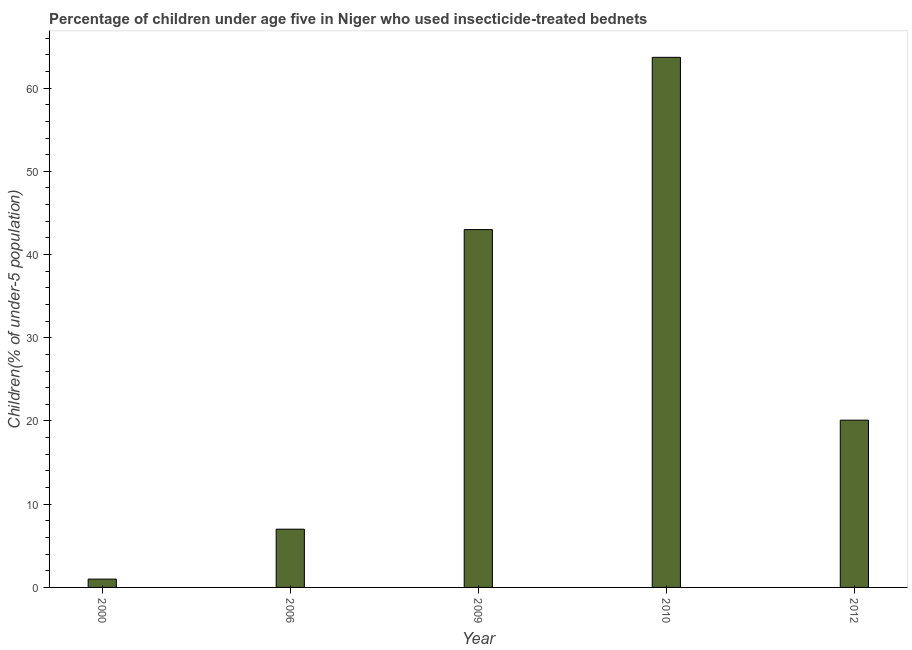What is the title of the graph?
Give a very brief answer. Percentage of children under age five in Niger who used insecticide-treated bednets. What is the label or title of the X-axis?
Your answer should be very brief. Year. What is the label or title of the Y-axis?
Your answer should be compact. Children(% of under-5 population). What is the percentage of children who use of insecticide-treated bed nets in 2012?
Your response must be concise. 20.1. Across all years, what is the maximum percentage of children who use of insecticide-treated bed nets?
Make the answer very short. 63.7. Across all years, what is the minimum percentage of children who use of insecticide-treated bed nets?
Your answer should be compact. 1. What is the sum of the percentage of children who use of insecticide-treated bed nets?
Make the answer very short. 134.8. What is the difference between the percentage of children who use of insecticide-treated bed nets in 2006 and 2012?
Provide a succinct answer. -13.1. What is the average percentage of children who use of insecticide-treated bed nets per year?
Your answer should be compact. 26.96. What is the median percentage of children who use of insecticide-treated bed nets?
Ensure brevity in your answer.  20.1. Do a majority of the years between 2006 and 2012 (inclusive) have percentage of children who use of insecticide-treated bed nets greater than 44 %?
Your answer should be very brief. No. Is the percentage of children who use of insecticide-treated bed nets in 2009 less than that in 2012?
Provide a short and direct response. No. Is the difference between the percentage of children who use of insecticide-treated bed nets in 2006 and 2012 greater than the difference between any two years?
Keep it short and to the point. No. What is the difference between the highest and the second highest percentage of children who use of insecticide-treated bed nets?
Offer a very short reply. 20.7. What is the difference between the highest and the lowest percentage of children who use of insecticide-treated bed nets?
Your response must be concise. 62.7. In how many years, is the percentage of children who use of insecticide-treated bed nets greater than the average percentage of children who use of insecticide-treated bed nets taken over all years?
Your response must be concise. 2. Are all the bars in the graph horizontal?
Provide a succinct answer. No. What is the Children(% of under-5 population) in 2000?
Offer a terse response. 1. What is the Children(% of under-5 population) in 2010?
Keep it short and to the point. 63.7. What is the Children(% of under-5 population) of 2012?
Provide a short and direct response. 20.1. What is the difference between the Children(% of under-5 population) in 2000 and 2009?
Your answer should be very brief. -42. What is the difference between the Children(% of under-5 population) in 2000 and 2010?
Make the answer very short. -62.7. What is the difference between the Children(% of under-5 population) in 2000 and 2012?
Offer a terse response. -19.1. What is the difference between the Children(% of under-5 population) in 2006 and 2009?
Make the answer very short. -36. What is the difference between the Children(% of under-5 population) in 2006 and 2010?
Your answer should be very brief. -56.7. What is the difference between the Children(% of under-5 population) in 2009 and 2010?
Make the answer very short. -20.7. What is the difference between the Children(% of under-5 population) in 2009 and 2012?
Provide a succinct answer. 22.9. What is the difference between the Children(% of under-5 population) in 2010 and 2012?
Your answer should be compact. 43.6. What is the ratio of the Children(% of under-5 population) in 2000 to that in 2006?
Provide a short and direct response. 0.14. What is the ratio of the Children(% of under-5 population) in 2000 to that in 2009?
Offer a very short reply. 0.02. What is the ratio of the Children(% of under-5 population) in 2000 to that in 2010?
Make the answer very short. 0.02. What is the ratio of the Children(% of under-5 population) in 2000 to that in 2012?
Make the answer very short. 0.05. What is the ratio of the Children(% of under-5 population) in 2006 to that in 2009?
Ensure brevity in your answer.  0.16. What is the ratio of the Children(% of under-5 population) in 2006 to that in 2010?
Keep it short and to the point. 0.11. What is the ratio of the Children(% of under-5 population) in 2006 to that in 2012?
Ensure brevity in your answer.  0.35. What is the ratio of the Children(% of under-5 population) in 2009 to that in 2010?
Give a very brief answer. 0.68. What is the ratio of the Children(% of under-5 population) in 2009 to that in 2012?
Your answer should be very brief. 2.14. What is the ratio of the Children(% of under-5 population) in 2010 to that in 2012?
Provide a succinct answer. 3.17. 